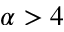<formula> <loc_0><loc_0><loc_500><loc_500>\alpha > 4</formula> 